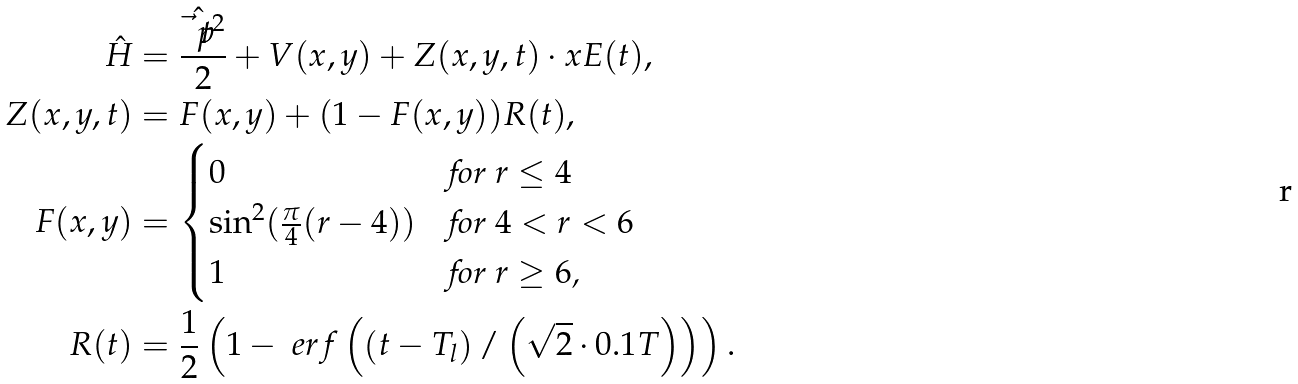<formula> <loc_0><loc_0><loc_500><loc_500>\hat { H } & = \frac { \hat { \vec { t } { p } } ^ { 2 } } { 2 } + V ( x , y ) + Z ( x , y , t ) \cdot x E ( t ) , \\ Z ( x , y , t ) & = F ( x , y ) + ( 1 - F ( x , y ) ) R ( t ) , \\ F ( x , y ) & = \begin{cases} 0 & \text {for $r \leq 4$} \\ \sin ^ { 2 } ( \frac { \pi } { 4 } ( r - 4 ) ) & \text {for $4 < r < 6$} \\ 1 & \text {for $r \geq 6$,} \end{cases} \\ R ( t ) & = \frac { 1 } { 2 } \left ( 1 - \ e r f \left ( \left ( t - T _ { l } \right ) / \left ( \sqrt { 2 } \cdot 0 . 1 T \right ) \right ) \right ) .</formula> 